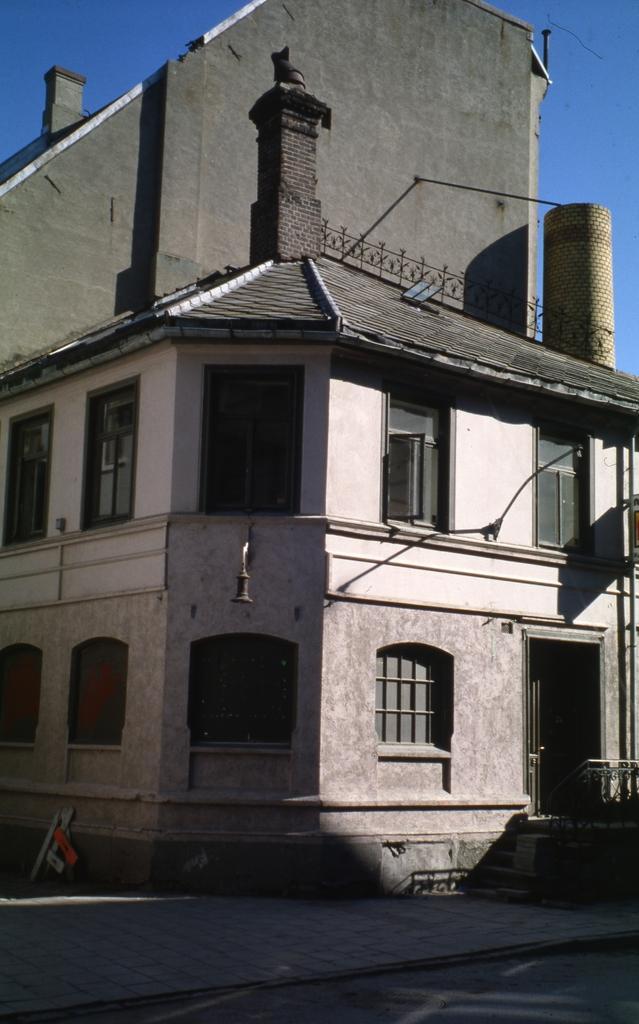Describe this image in one or two sentences. In this image there is a building and in front of the building there are stairs. At the back side there is sky. 